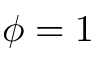<formula> <loc_0><loc_0><loc_500><loc_500>\phi = 1</formula> 